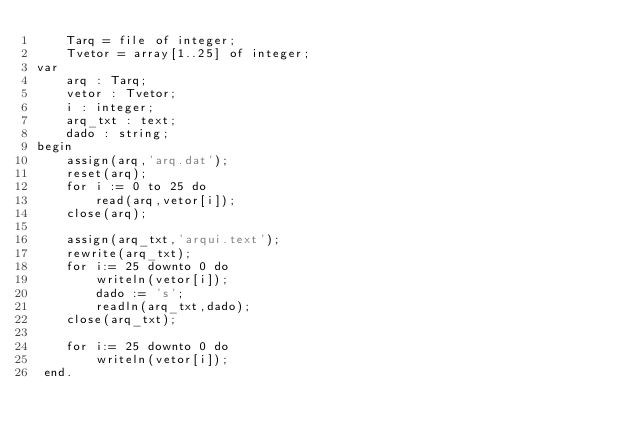<code> <loc_0><loc_0><loc_500><loc_500><_Pascal_>	Tarq = file of integer;
	Tvetor = array[1..25] of integer;
var
	arq : Tarq;
	vetor : Tvetor;
	i : integer;
	arq_txt : text;
	dado : string;
begin
	assign(arq,'arq.dat');
	reset(arq);
	for i := 0 to 25 do 
		read(arq,vetor[i]);
	close(arq);
	
	assign(arq_txt,'arqui.text');
	rewrite(arq_txt);
	for i:= 25 downto 0 do 
		writeln(vetor[i]);
		dado := 's';
		readln(arq_txt,dado);
	close(arq_txt);
	
	for i:= 25 downto 0 do 
		writeln(vetor[i]);
 end.
 </code> 